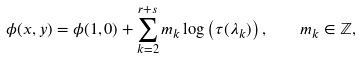<formula> <loc_0><loc_0><loc_500><loc_500>\phi ( x , y ) = \phi ( 1 , 0 ) + \sum _ { k = 2 } ^ { r + s } m _ { k } \log \left ( \tau ( \lambda _ { k } ) \right ) , \quad m _ { k } \in \mathbb { Z } ,</formula> 